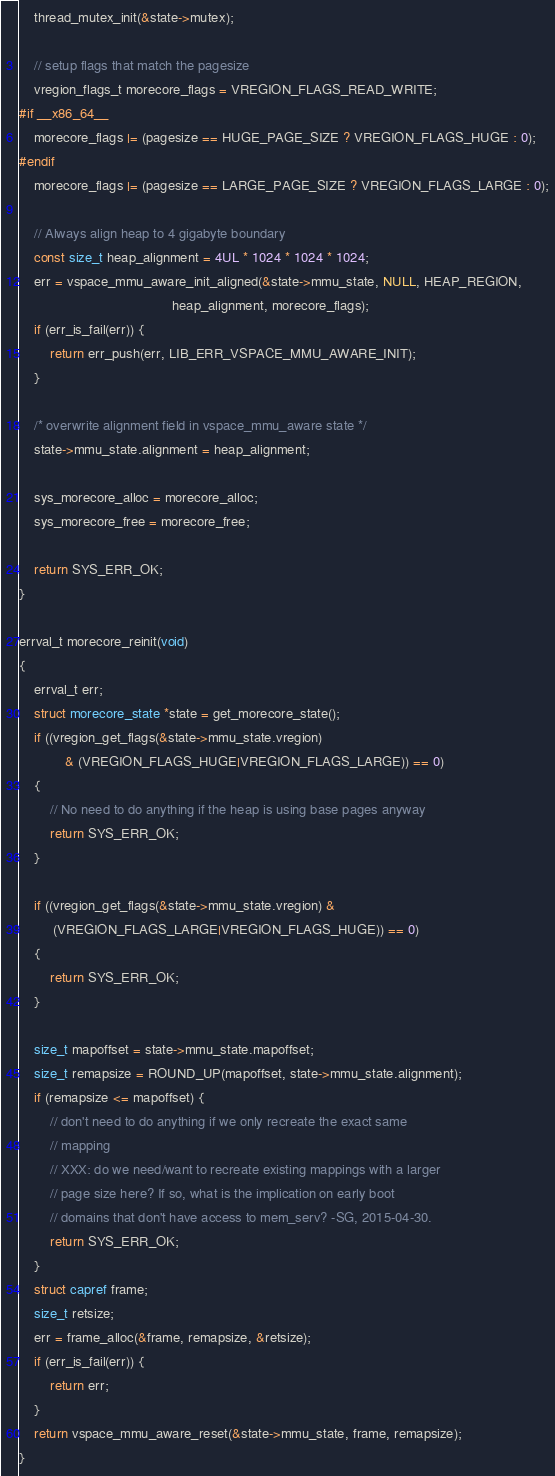<code> <loc_0><loc_0><loc_500><loc_500><_C_>
    thread_mutex_init(&state->mutex);

    // setup flags that match the pagesize
    vregion_flags_t morecore_flags = VREGION_FLAGS_READ_WRITE;
#if __x86_64__
    morecore_flags |= (pagesize == HUGE_PAGE_SIZE ? VREGION_FLAGS_HUGE : 0);
#endif
    morecore_flags |= (pagesize == LARGE_PAGE_SIZE ? VREGION_FLAGS_LARGE : 0);

    // Always align heap to 4 gigabyte boundary
    const size_t heap_alignment = 4UL * 1024 * 1024 * 1024;
    err = vspace_mmu_aware_init_aligned(&state->mmu_state, NULL, HEAP_REGION,
                                        heap_alignment, morecore_flags);
    if (err_is_fail(err)) {
        return err_push(err, LIB_ERR_VSPACE_MMU_AWARE_INIT);
    }

    /* overwrite alignment field in vspace_mmu_aware state */
    state->mmu_state.alignment = heap_alignment;

    sys_morecore_alloc = morecore_alloc;
    sys_morecore_free = morecore_free;

    return SYS_ERR_OK;
}

errval_t morecore_reinit(void)
{
    errval_t err;
    struct morecore_state *state = get_morecore_state();
    if ((vregion_get_flags(&state->mmu_state.vregion)
            & (VREGION_FLAGS_HUGE|VREGION_FLAGS_LARGE)) == 0)
    {
        // No need to do anything if the heap is using base pages anyway
        return SYS_ERR_OK;
    }

    if ((vregion_get_flags(&state->mmu_state.vregion) &
         (VREGION_FLAGS_LARGE|VREGION_FLAGS_HUGE)) == 0)
    {
        return SYS_ERR_OK;
    }

    size_t mapoffset = state->mmu_state.mapoffset;
    size_t remapsize = ROUND_UP(mapoffset, state->mmu_state.alignment);
    if (remapsize <= mapoffset) {
        // don't need to do anything if we only recreate the exact same
        // mapping
        // XXX: do we need/want to recreate existing mappings with a larger
        // page size here? If so, what is the implication on early boot
        // domains that don't have access to mem_serv? -SG, 2015-04-30.
        return SYS_ERR_OK;
    }
    struct capref frame;
    size_t retsize;
    err = frame_alloc(&frame, remapsize, &retsize);
    if (err_is_fail(err)) {
        return err;
    }
    return vspace_mmu_aware_reset(&state->mmu_state, frame, remapsize);
}
</code> 